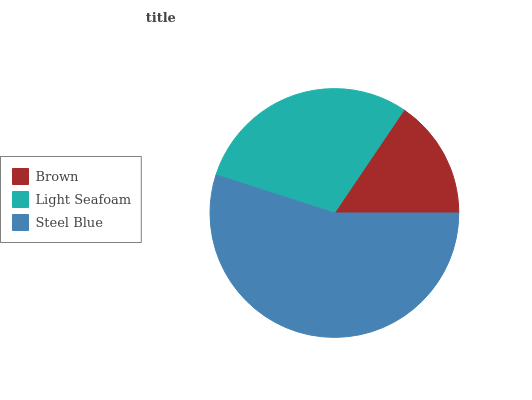Is Brown the minimum?
Answer yes or no. Yes. Is Steel Blue the maximum?
Answer yes or no. Yes. Is Light Seafoam the minimum?
Answer yes or no. No. Is Light Seafoam the maximum?
Answer yes or no. No. Is Light Seafoam greater than Brown?
Answer yes or no. Yes. Is Brown less than Light Seafoam?
Answer yes or no. Yes. Is Brown greater than Light Seafoam?
Answer yes or no. No. Is Light Seafoam less than Brown?
Answer yes or no. No. Is Light Seafoam the high median?
Answer yes or no. Yes. Is Light Seafoam the low median?
Answer yes or no. Yes. Is Steel Blue the high median?
Answer yes or no. No. Is Brown the low median?
Answer yes or no. No. 